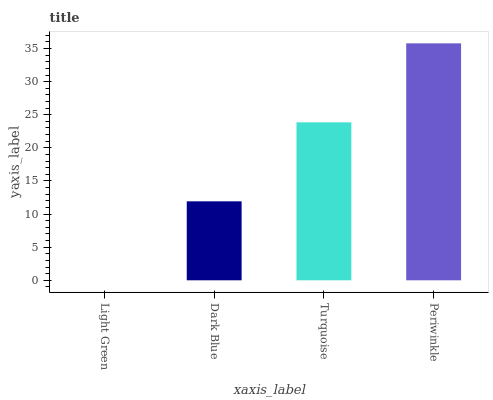Is Light Green the minimum?
Answer yes or no. Yes. Is Periwinkle the maximum?
Answer yes or no. Yes. Is Dark Blue the minimum?
Answer yes or no. No. Is Dark Blue the maximum?
Answer yes or no. No. Is Dark Blue greater than Light Green?
Answer yes or no. Yes. Is Light Green less than Dark Blue?
Answer yes or no. Yes. Is Light Green greater than Dark Blue?
Answer yes or no. No. Is Dark Blue less than Light Green?
Answer yes or no. No. Is Turquoise the high median?
Answer yes or no. Yes. Is Dark Blue the low median?
Answer yes or no. Yes. Is Light Green the high median?
Answer yes or no. No. Is Light Green the low median?
Answer yes or no. No. 